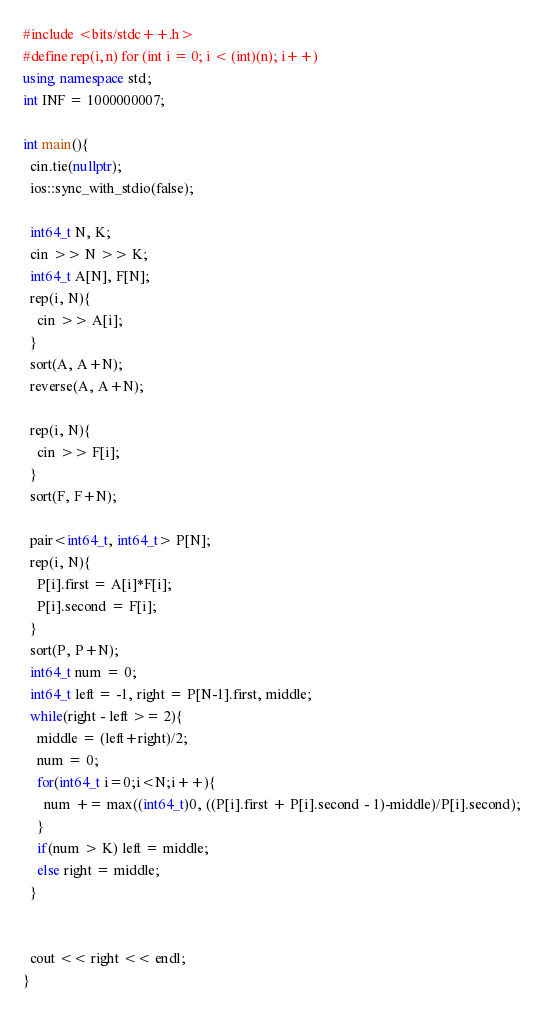<code> <loc_0><loc_0><loc_500><loc_500><_C++_>#include <bits/stdc++.h>
#define rep(i, n) for (int i = 0; i < (int)(n); i++)
using namespace std;
int INF = 1000000007;

int main(){
  cin.tie(nullptr);
  ios::sync_with_stdio(false);

  int64_t N, K;
  cin >> N >> K;
  int64_t A[N], F[N];
  rep(i, N){
    cin >> A[i];
  }
  sort(A, A+N);
  reverse(A, A+N);

  rep(i, N){
    cin >> F[i];
  }
  sort(F, F+N);

  pair<int64_t, int64_t> P[N];
  rep(i, N){
    P[i].first = A[i]*F[i];
    P[i].second = F[i];
  }
  sort(P, P+N);
  int64_t num = 0;
  int64_t left = -1, right = P[N-1].first, middle;
  while(right - left >= 2){
    middle = (left+right)/2;
    num = 0;
    for(int64_t i=0;i<N;i++){
      num += max((int64_t)0, ((P[i].first + P[i].second - 1)-middle)/P[i].second);
    }
    if(num > K) left = middle;
    else right = middle;
  }


  cout << right << endl;
}</code> 